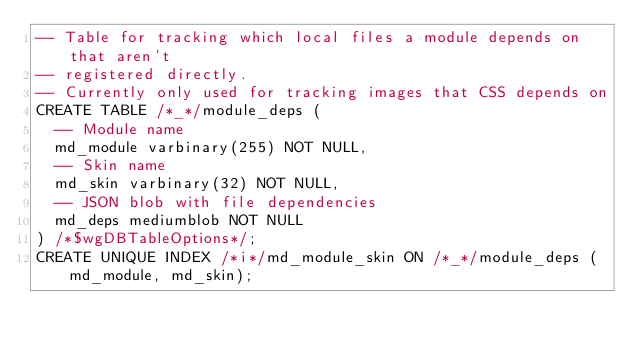<code> <loc_0><loc_0><loc_500><loc_500><_SQL_>-- Table for tracking which local files a module depends on that aren't
-- registered directly.
-- Currently only used for tracking images that CSS depends on
CREATE TABLE /*_*/module_deps (
  -- Module name
  md_module varbinary(255) NOT NULL,
  -- Skin name
  md_skin varbinary(32) NOT NULL,
  -- JSON blob with file dependencies
  md_deps mediumblob NOT NULL
) /*$wgDBTableOptions*/;
CREATE UNIQUE INDEX /*i*/md_module_skin ON /*_*/module_deps (md_module, md_skin);
</code> 